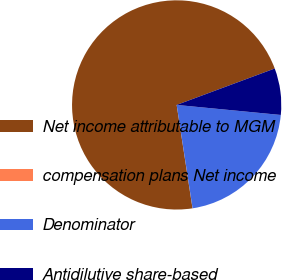<chart> <loc_0><loc_0><loc_500><loc_500><pie_chart><fcel>Net income attributable to MGM<fcel>compensation plans Net income<fcel>Denominator<fcel>Antidilutive share-based<nl><fcel>71.77%<fcel>0.01%<fcel>21.04%<fcel>7.19%<nl></chart> 